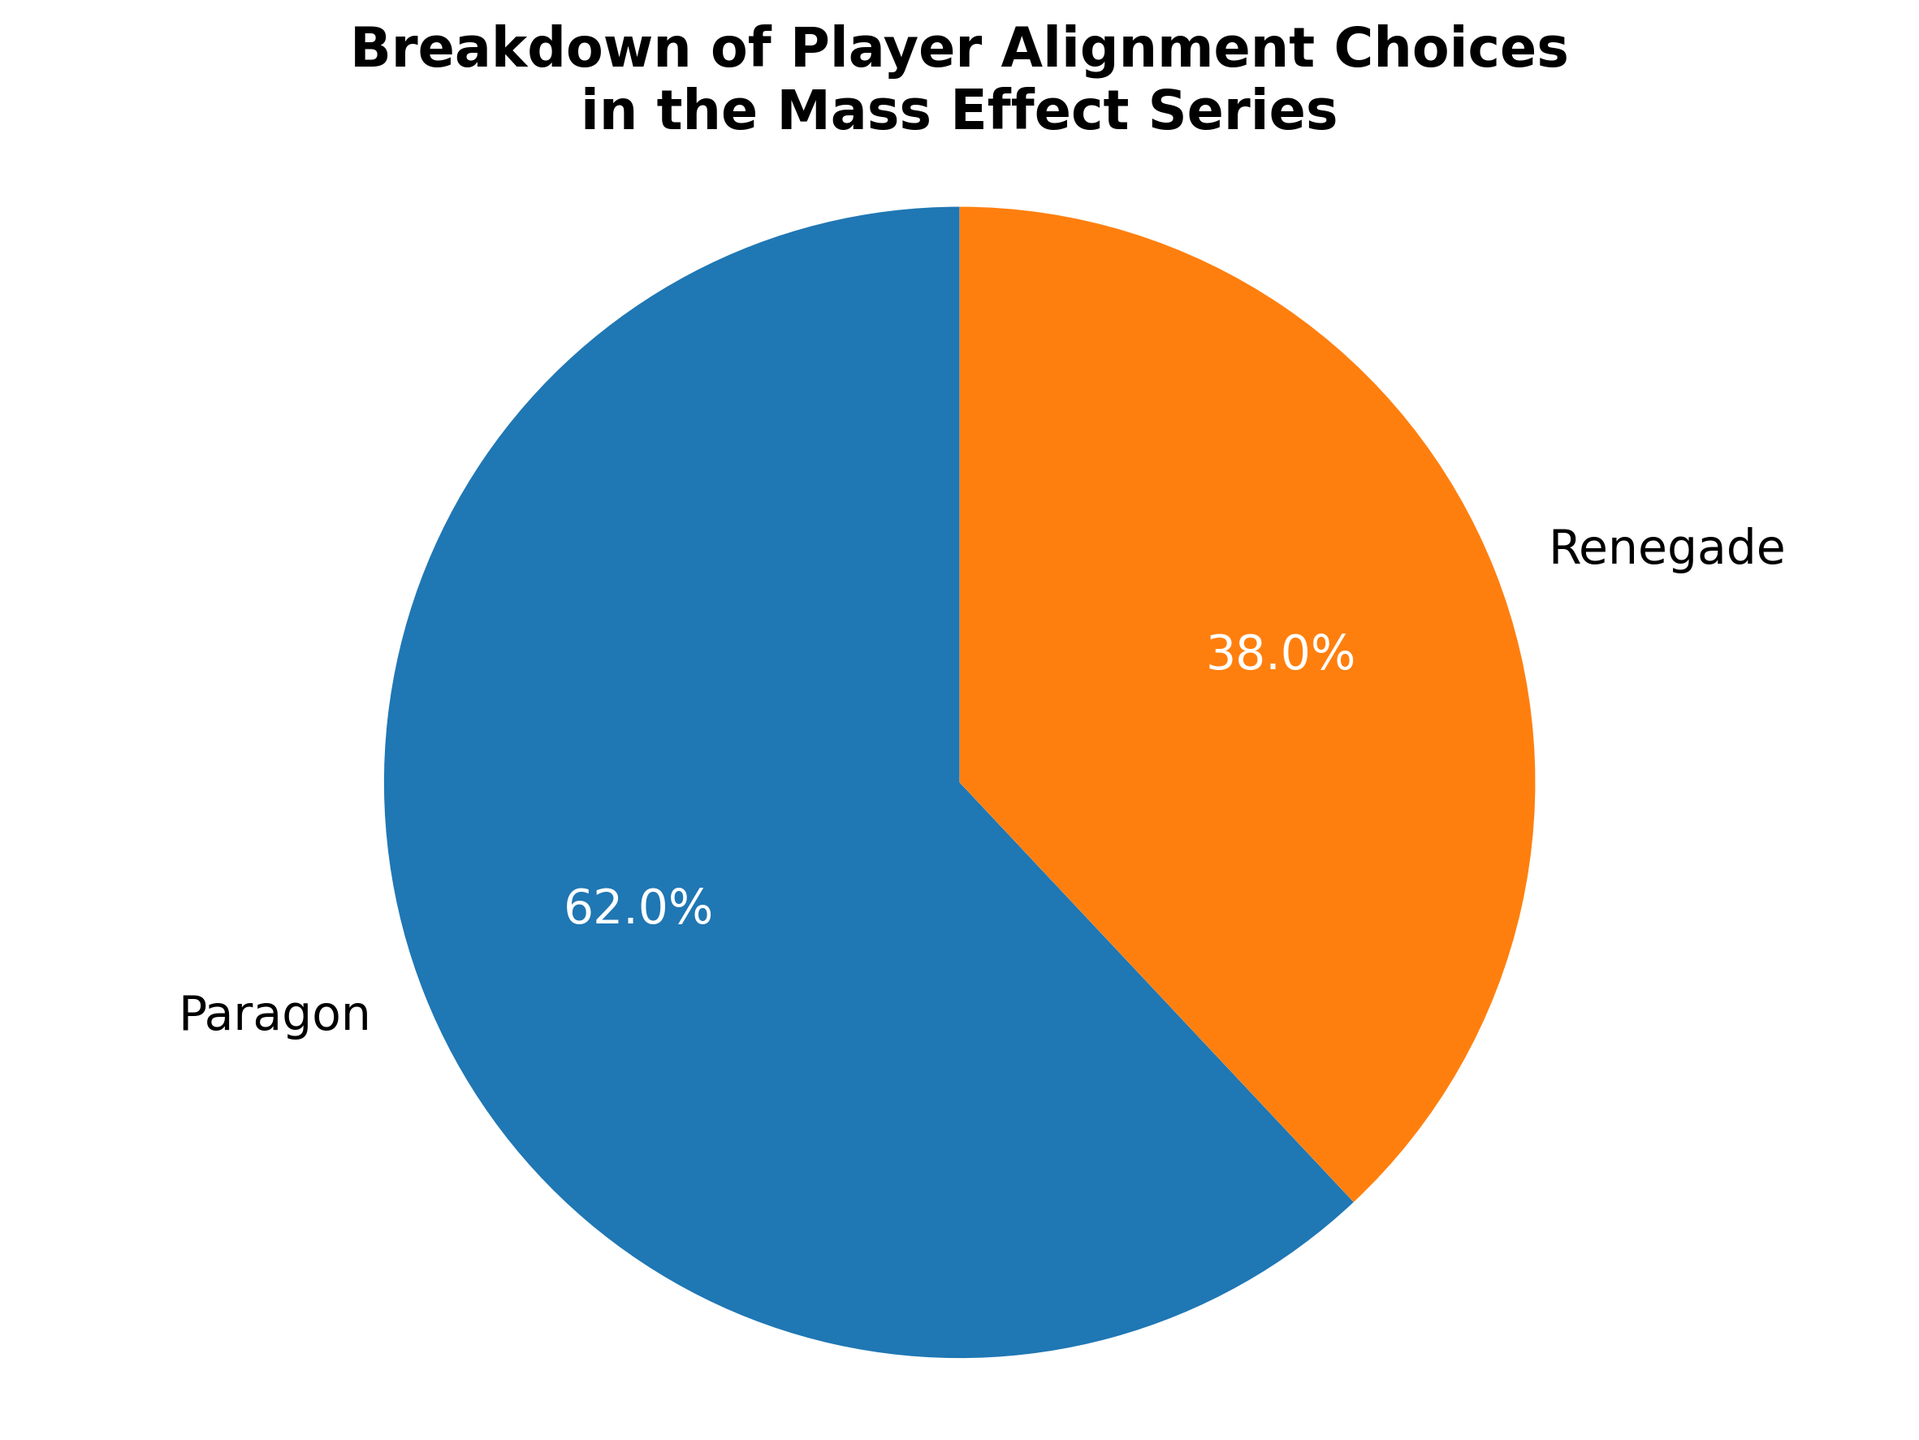What percentage of players chose Paragon? The figure shows a pie chart with two slices, one for Paragon and one for Renegade. The percentage labeled next to Paragon is 62%.
Answer: 62% What percentage of players chose Renegade? The figure shows a pie chart with two slices, one for Paragon and one for Renegade. The percentage labeled next to Renegade is 38%.
Answer: 38% Which alignment choice did the majority of players select? The pie chart shows two segments: Paragon at 62% and Renegade at 38%. Since 62% is greater than 38%, the majority of players selected Paragon.
Answer: Paragon By how much does the percentage of Paragon players exceed the percentage of Renegade players? The percentage of players choosing Paragon is 62%, and the percentage for Renegade is 38%. To find the difference, subtract 38% from 62%, which results in 24%.
Answer: 24% What fraction of the players chose Renegade in simplest form? The percentage of players who chose Renegade is 38%. Converting this to a fraction, we get 38/100, which simplifies to 19/50.
Answer: 19/50 Based on the pie chart, is it fair to say that the majority of players prefer to play as a hero (Paragon)? Yes, since 62% of players chose Paragon, compared to 38% who chose Renegade, the majority indeed prefer to play as a hero.
Answer: Yes What are the colors used to represent the different alignment choices in the pie chart? The slice for Paragon is colored blue, and the slice for Renegade is colored orange. These colors differentiate the two alignment choices visually.
Answer: Blue and Orange What is the total percentage represented on the pie chart? The pie chart represents Paragon with 62% and Renegade with 38%. Adding these percentages together gives 62% + 38% = 100%.
Answer: 100% If the game had 1,000,000 players, how many selected each alignment? To find the number of players who chose each alignment, multiply the total number of players (1,000,000) by the percentage for each alignment. For Paragon, it's 1,000,000 * 0.62 = 620,000. For Renegade, it's 1,000,000 * 0.38 = 380,000.
Answer: 620,000 Paragon, 380,000 Renegade What segment starts at the 90-degree angle in the pie chart? The pie chart starts with the Paragon segment at the 90-degree angle because the chart typically starts drawing slices from the top (12 o'clock position).
Answer: Paragon 